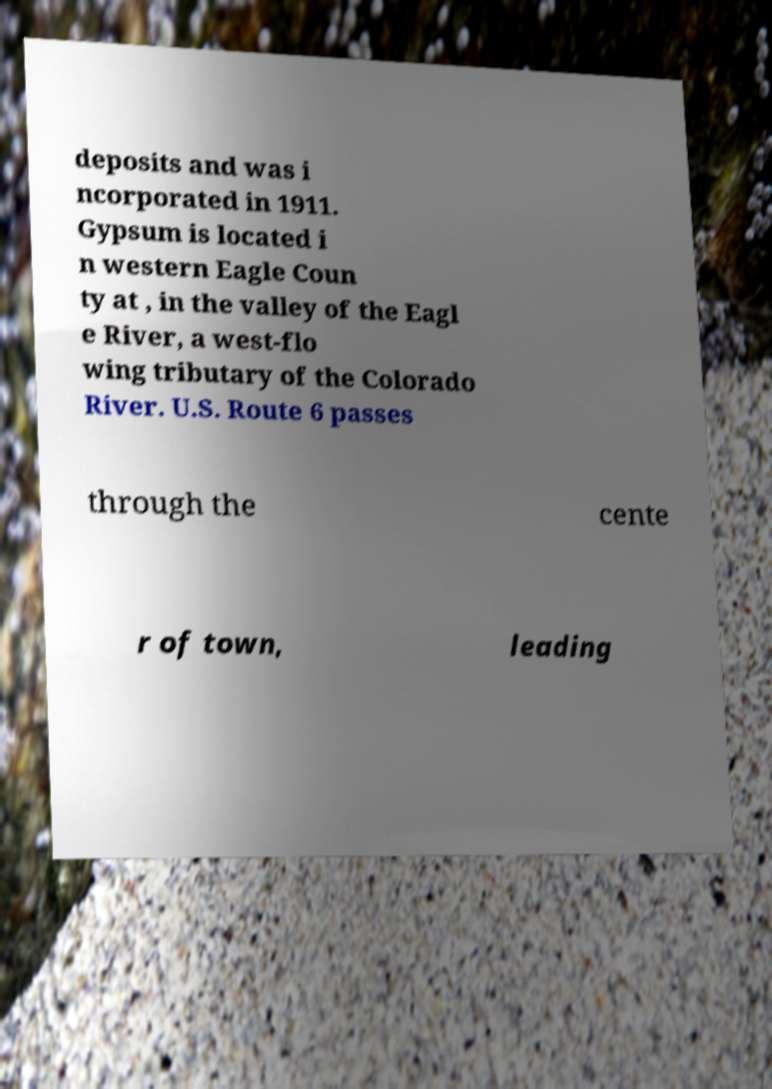Could you extract and type out the text from this image? deposits and was i ncorporated in 1911. Gypsum is located i n western Eagle Coun ty at , in the valley of the Eagl e River, a west-flo wing tributary of the Colorado River. U.S. Route 6 passes through the cente r of town, leading 